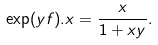<formula> <loc_0><loc_0><loc_500><loc_500>\exp ( y f ) . x = \frac { x } { 1 + x y } .</formula> 